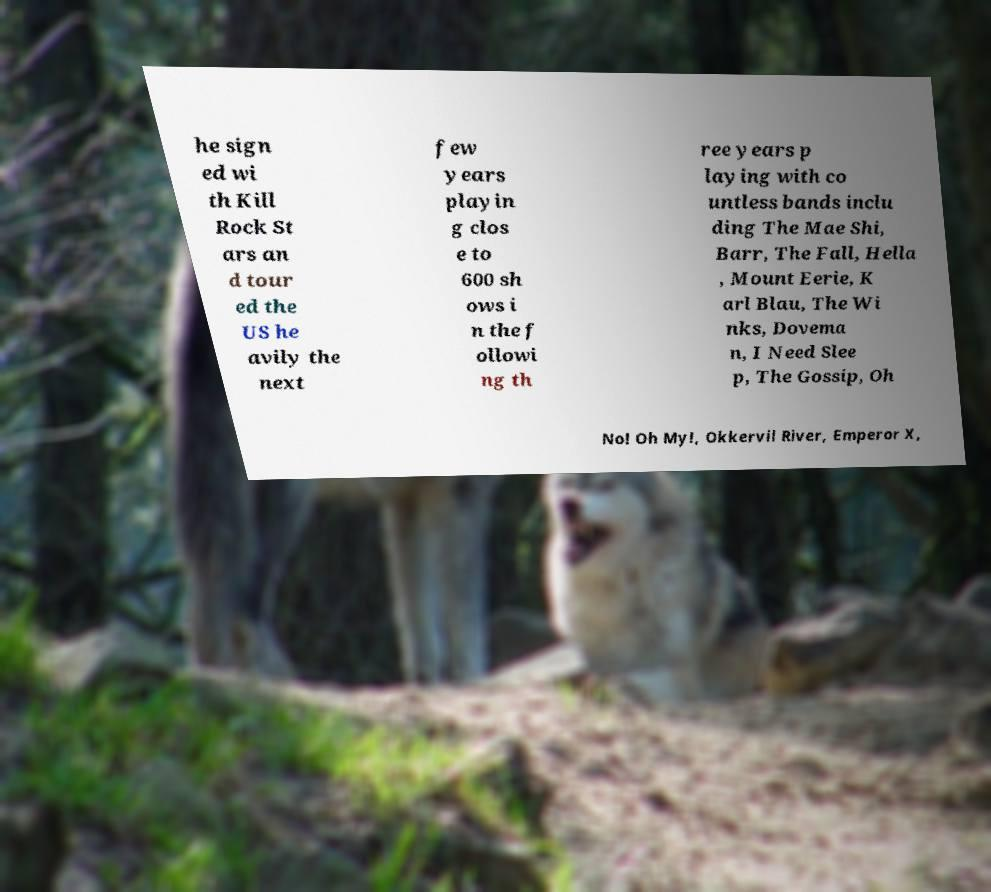There's text embedded in this image that I need extracted. Can you transcribe it verbatim? he sign ed wi th Kill Rock St ars an d tour ed the US he avily the next few years playin g clos e to 600 sh ows i n the f ollowi ng th ree years p laying with co untless bands inclu ding The Mae Shi, Barr, The Fall, Hella , Mount Eerie, K arl Blau, The Wi nks, Dovema n, I Need Slee p, The Gossip, Oh No! Oh My!, Okkervil River, Emperor X, 